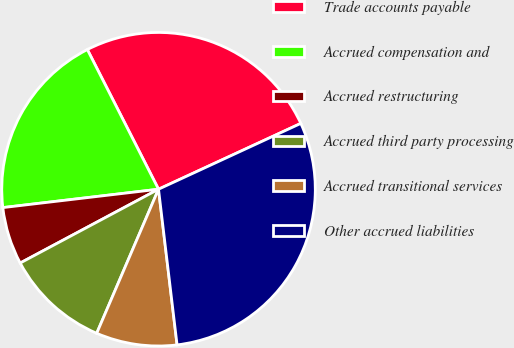Convert chart to OTSL. <chart><loc_0><loc_0><loc_500><loc_500><pie_chart><fcel>Trade accounts payable<fcel>Accrued compensation and<fcel>Accrued restructuring<fcel>Accrued third party processing<fcel>Accrued transitional services<fcel>Other accrued liabilities<nl><fcel>25.61%<fcel>19.37%<fcel>5.93%<fcel>10.75%<fcel>8.34%<fcel>30.01%<nl></chart> 